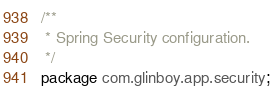<code> <loc_0><loc_0><loc_500><loc_500><_Java_>/**
 * Spring Security configuration.
 */
package com.glinboy.app.security;
</code> 